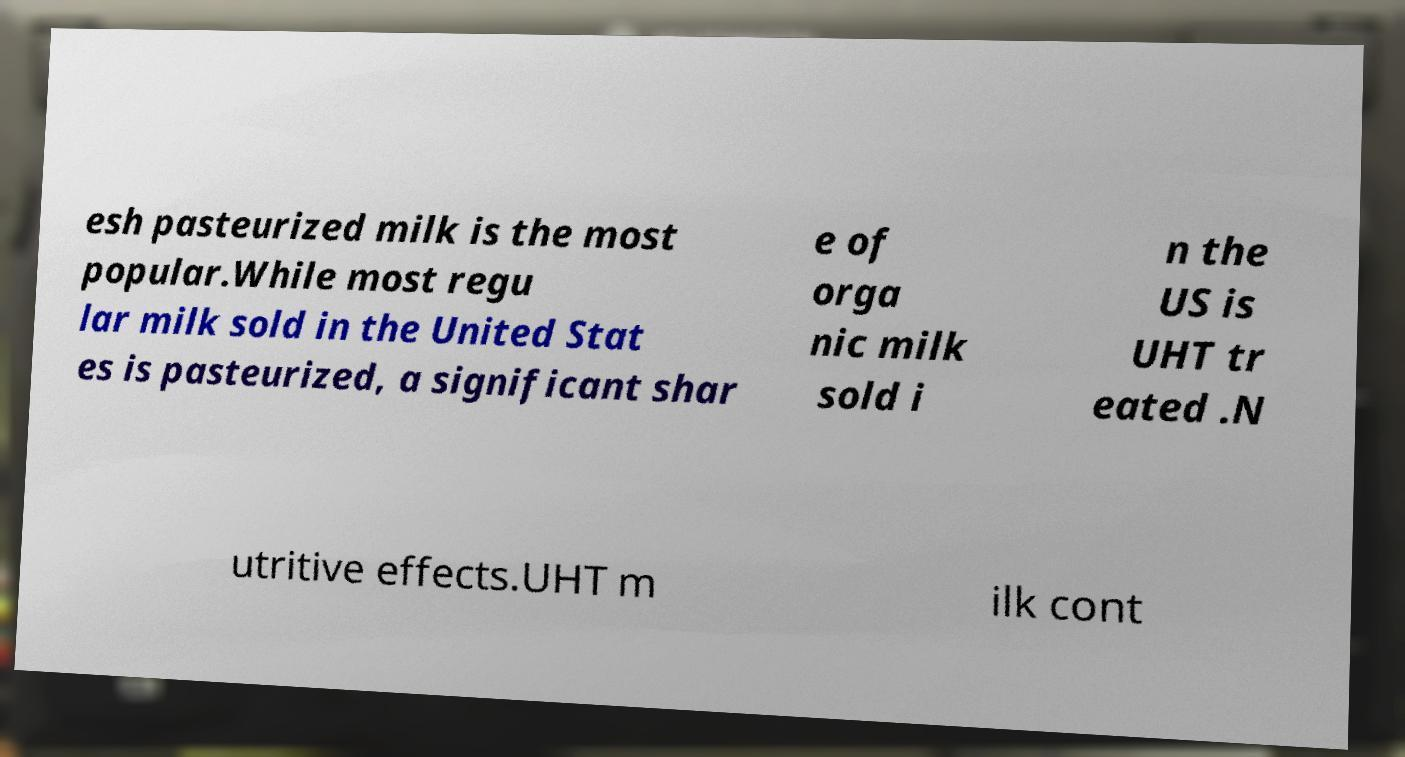Can you accurately transcribe the text from the provided image for me? esh pasteurized milk is the most popular.While most regu lar milk sold in the United Stat es is pasteurized, a significant shar e of orga nic milk sold i n the US is UHT tr eated .N utritive effects.UHT m ilk cont 